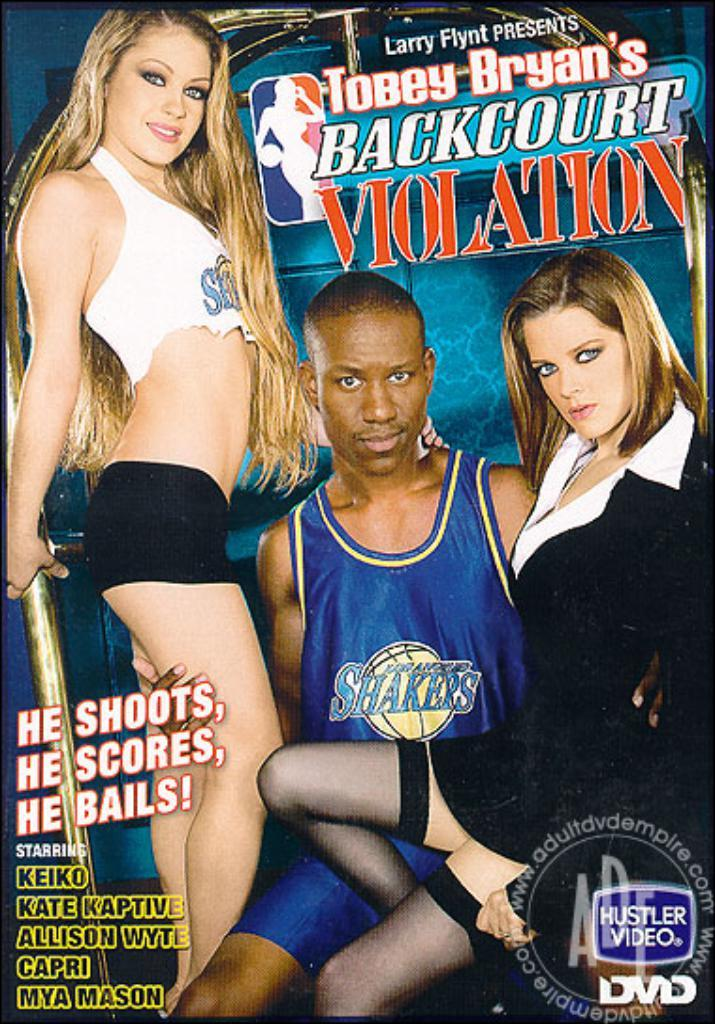<image>
Describe the image concisely. A cover of a porn video featuring a basketball player says he shoots, he scores... 